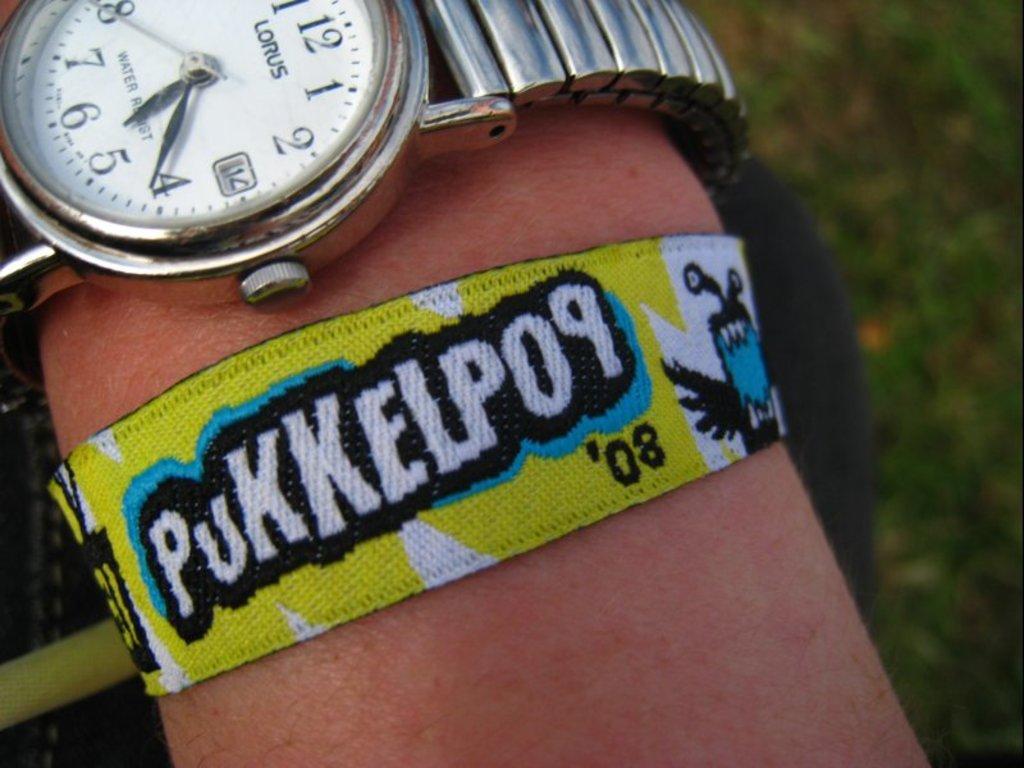What brand of watch is shown?
Your answer should be very brief. Lorus. What year is the bracelet from?
Offer a terse response. 2008. 